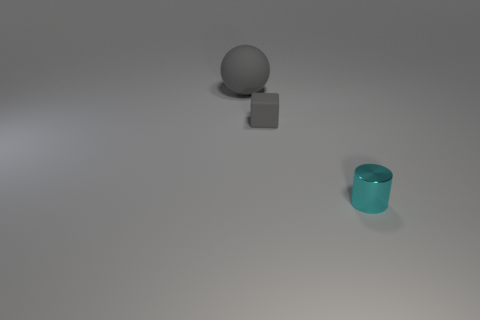Add 2 large red matte things. How many objects exist? 5 Subtract 0 gray cylinders. How many objects are left? 3 Subtract all blocks. How many objects are left? 2 Subtract all big gray matte things. Subtract all large gray balls. How many objects are left? 1 Add 2 big rubber balls. How many big rubber balls are left? 3 Add 2 big green rubber spheres. How many big green rubber spheres exist? 2 